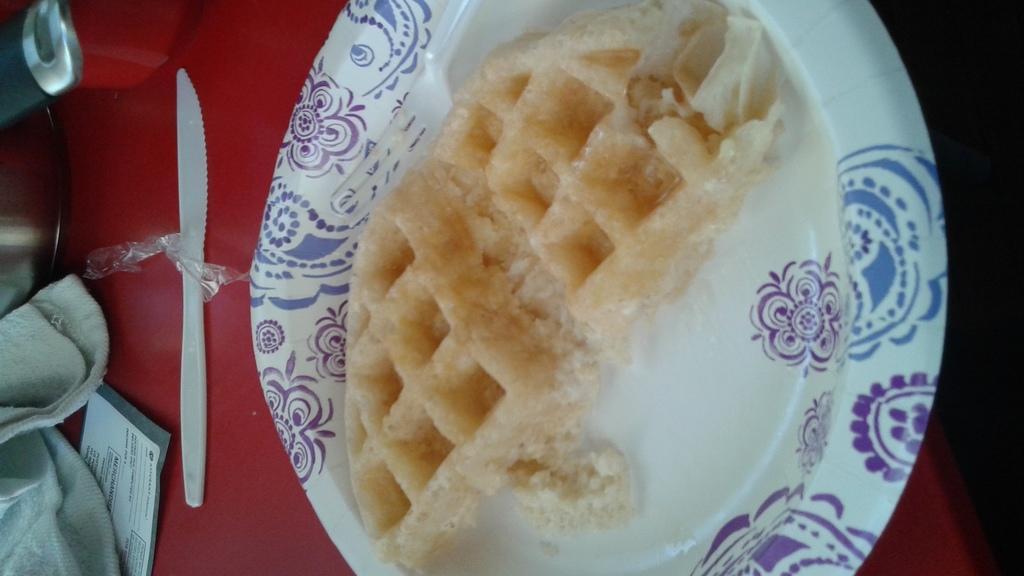Could you give a brief overview of what you see in this image? In the center of the image there is a table. On the table we can see vessel, knife, cloth, paper, plate contain food item, fork are present. 